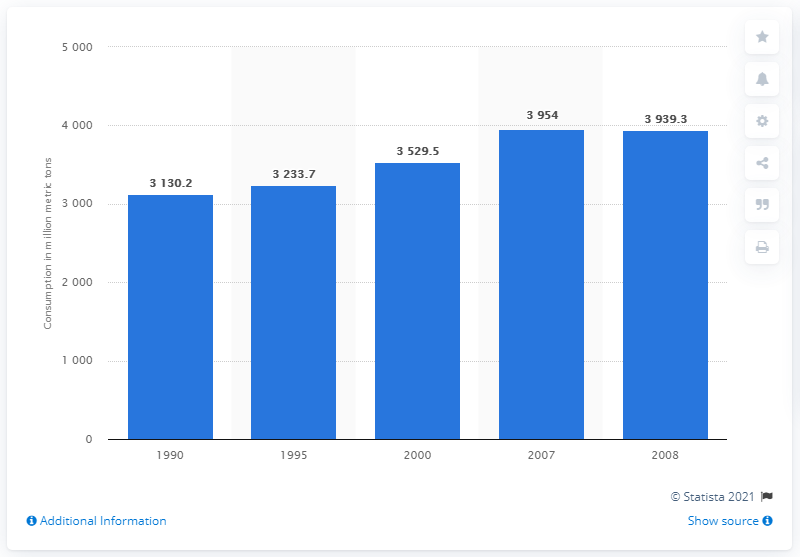Indicate a few pertinent items in this graphic. In the year 2007, the world consumed four billion metric tons of crude oil. 